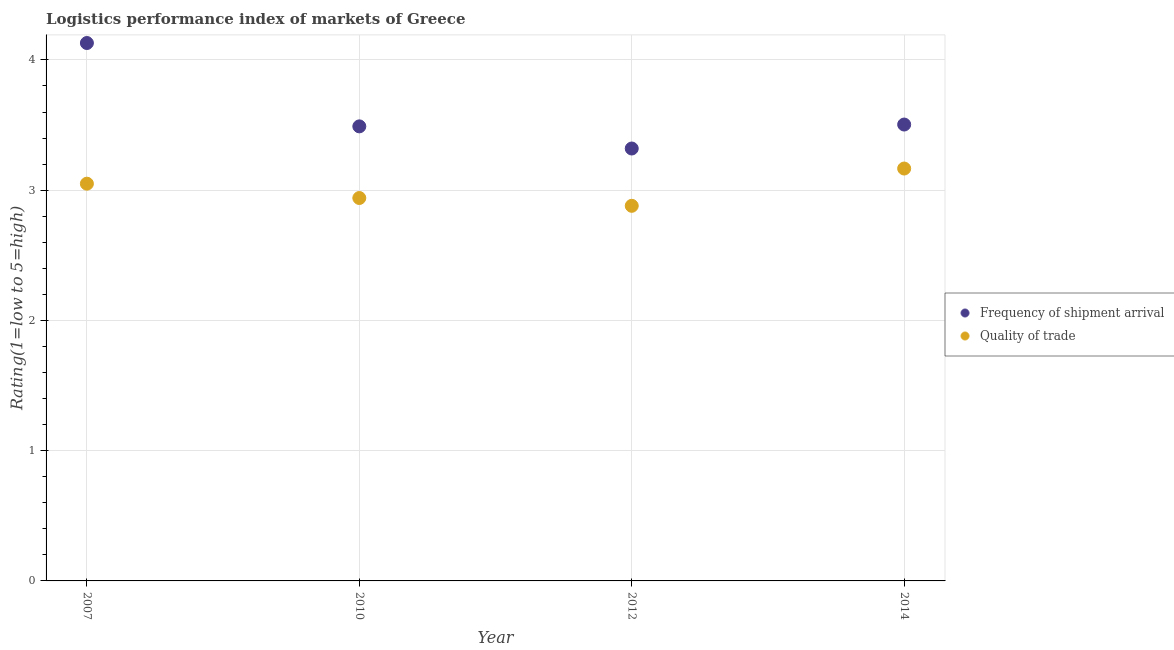Is the number of dotlines equal to the number of legend labels?
Your answer should be compact. Yes. What is the lpi quality of trade in 2007?
Provide a succinct answer. 3.05. Across all years, what is the maximum lpi quality of trade?
Ensure brevity in your answer.  3.17. Across all years, what is the minimum lpi of frequency of shipment arrival?
Provide a short and direct response. 3.32. In which year was the lpi of frequency of shipment arrival maximum?
Provide a short and direct response. 2007. In which year was the lpi quality of trade minimum?
Your response must be concise. 2012. What is the total lpi quality of trade in the graph?
Provide a short and direct response. 12.04. What is the difference between the lpi of frequency of shipment arrival in 2010 and that in 2012?
Ensure brevity in your answer.  0.17. What is the difference between the lpi quality of trade in 2010 and the lpi of frequency of shipment arrival in 2014?
Your response must be concise. -0.56. What is the average lpi of frequency of shipment arrival per year?
Offer a very short reply. 3.61. In the year 2014, what is the difference between the lpi quality of trade and lpi of frequency of shipment arrival?
Offer a terse response. -0.34. What is the ratio of the lpi quality of trade in 2007 to that in 2012?
Provide a short and direct response. 1.06. Is the difference between the lpi quality of trade in 2012 and 2014 greater than the difference between the lpi of frequency of shipment arrival in 2012 and 2014?
Give a very brief answer. No. What is the difference between the highest and the second highest lpi of frequency of shipment arrival?
Provide a succinct answer. 0.63. What is the difference between the highest and the lowest lpi quality of trade?
Provide a short and direct response. 0.29. Does the lpi of frequency of shipment arrival monotonically increase over the years?
Make the answer very short. No. Is the lpi of frequency of shipment arrival strictly greater than the lpi quality of trade over the years?
Offer a very short reply. Yes. How many dotlines are there?
Give a very brief answer. 2. How many years are there in the graph?
Keep it short and to the point. 4. What is the difference between two consecutive major ticks on the Y-axis?
Give a very brief answer. 1. Are the values on the major ticks of Y-axis written in scientific E-notation?
Your answer should be very brief. No. Does the graph contain grids?
Keep it short and to the point. Yes. How many legend labels are there?
Provide a succinct answer. 2. How are the legend labels stacked?
Offer a terse response. Vertical. What is the title of the graph?
Give a very brief answer. Logistics performance index of markets of Greece. What is the label or title of the Y-axis?
Provide a succinct answer. Rating(1=low to 5=high). What is the Rating(1=low to 5=high) in Frequency of shipment arrival in 2007?
Your answer should be very brief. 4.13. What is the Rating(1=low to 5=high) in Quality of trade in 2007?
Your answer should be very brief. 3.05. What is the Rating(1=low to 5=high) in Frequency of shipment arrival in 2010?
Ensure brevity in your answer.  3.49. What is the Rating(1=low to 5=high) of Quality of trade in 2010?
Provide a succinct answer. 2.94. What is the Rating(1=low to 5=high) in Frequency of shipment arrival in 2012?
Your answer should be compact. 3.32. What is the Rating(1=low to 5=high) of Quality of trade in 2012?
Provide a short and direct response. 2.88. What is the Rating(1=low to 5=high) in Frequency of shipment arrival in 2014?
Provide a short and direct response. 3.5. What is the Rating(1=low to 5=high) of Quality of trade in 2014?
Your answer should be very brief. 3.17. Across all years, what is the maximum Rating(1=low to 5=high) of Frequency of shipment arrival?
Offer a very short reply. 4.13. Across all years, what is the maximum Rating(1=low to 5=high) of Quality of trade?
Provide a short and direct response. 3.17. Across all years, what is the minimum Rating(1=low to 5=high) of Frequency of shipment arrival?
Provide a succinct answer. 3.32. Across all years, what is the minimum Rating(1=low to 5=high) of Quality of trade?
Give a very brief answer. 2.88. What is the total Rating(1=low to 5=high) of Frequency of shipment arrival in the graph?
Ensure brevity in your answer.  14.44. What is the total Rating(1=low to 5=high) in Quality of trade in the graph?
Offer a terse response. 12.04. What is the difference between the Rating(1=low to 5=high) in Frequency of shipment arrival in 2007 and that in 2010?
Your answer should be very brief. 0.64. What is the difference between the Rating(1=low to 5=high) of Quality of trade in 2007 and that in 2010?
Provide a succinct answer. 0.11. What is the difference between the Rating(1=low to 5=high) of Frequency of shipment arrival in 2007 and that in 2012?
Offer a terse response. 0.81. What is the difference between the Rating(1=low to 5=high) of Quality of trade in 2007 and that in 2012?
Your answer should be compact. 0.17. What is the difference between the Rating(1=low to 5=high) in Frequency of shipment arrival in 2007 and that in 2014?
Provide a short and direct response. 0.63. What is the difference between the Rating(1=low to 5=high) in Quality of trade in 2007 and that in 2014?
Keep it short and to the point. -0.12. What is the difference between the Rating(1=low to 5=high) of Frequency of shipment arrival in 2010 and that in 2012?
Your answer should be very brief. 0.17. What is the difference between the Rating(1=low to 5=high) of Frequency of shipment arrival in 2010 and that in 2014?
Provide a short and direct response. -0.01. What is the difference between the Rating(1=low to 5=high) in Quality of trade in 2010 and that in 2014?
Ensure brevity in your answer.  -0.23. What is the difference between the Rating(1=low to 5=high) in Frequency of shipment arrival in 2012 and that in 2014?
Make the answer very short. -0.18. What is the difference between the Rating(1=low to 5=high) in Quality of trade in 2012 and that in 2014?
Provide a succinct answer. -0.29. What is the difference between the Rating(1=low to 5=high) in Frequency of shipment arrival in 2007 and the Rating(1=low to 5=high) in Quality of trade in 2010?
Give a very brief answer. 1.19. What is the difference between the Rating(1=low to 5=high) in Frequency of shipment arrival in 2007 and the Rating(1=low to 5=high) in Quality of trade in 2014?
Offer a very short reply. 0.96. What is the difference between the Rating(1=low to 5=high) of Frequency of shipment arrival in 2010 and the Rating(1=low to 5=high) of Quality of trade in 2012?
Offer a very short reply. 0.61. What is the difference between the Rating(1=low to 5=high) of Frequency of shipment arrival in 2010 and the Rating(1=low to 5=high) of Quality of trade in 2014?
Offer a very short reply. 0.32. What is the difference between the Rating(1=low to 5=high) in Frequency of shipment arrival in 2012 and the Rating(1=low to 5=high) in Quality of trade in 2014?
Provide a succinct answer. 0.15. What is the average Rating(1=low to 5=high) in Frequency of shipment arrival per year?
Make the answer very short. 3.61. What is the average Rating(1=low to 5=high) of Quality of trade per year?
Make the answer very short. 3.01. In the year 2010, what is the difference between the Rating(1=low to 5=high) in Frequency of shipment arrival and Rating(1=low to 5=high) in Quality of trade?
Make the answer very short. 0.55. In the year 2012, what is the difference between the Rating(1=low to 5=high) of Frequency of shipment arrival and Rating(1=low to 5=high) of Quality of trade?
Your answer should be compact. 0.44. In the year 2014, what is the difference between the Rating(1=low to 5=high) of Frequency of shipment arrival and Rating(1=low to 5=high) of Quality of trade?
Your response must be concise. 0.34. What is the ratio of the Rating(1=low to 5=high) in Frequency of shipment arrival in 2007 to that in 2010?
Offer a terse response. 1.18. What is the ratio of the Rating(1=low to 5=high) of Quality of trade in 2007 to that in 2010?
Provide a succinct answer. 1.04. What is the ratio of the Rating(1=low to 5=high) of Frequency of shipment arrival in 2007 to that in 2012?
Keep it short and to the point. 1.24. What is the ratio of the Rating(1=low to 5=high) in Quality of trade in 2007 to that in 2012?
Your answer should be very brief. 1.06. What is the ratio of the Rating(1=low to 5=high) in Frequency of shipment arrival in 2007 to that in 2014?
Your answer should be very brief. 1.18. What is the ratio of the Rating(1=low to 5=high) of Quality of trade in 2007 to that in 2014?
Your answer should be compact. 0.96. What is the ratio of the Rating(1=low to 5=high) of Frequency of shipment arrival in 2010 to that in 2012?
Offer a very short reply. 1.05. What is the ratio of the Rating(1=low to 5=high) of Quality of trade in 2010 to that in 2012?
Your response must be concise. 1.02. What is the ratio of the Rating(1=low to 5=high) in Frequency of shipment arrival in 2010 to that in 2014?
Give a very brief answer. 1. What is the ratio of the Rating(1=low to 5=high) in Quality of trade in 2010 to that in 2014?
Offer a terse response. 0.93. What is the ratio of the Rating(1=low to 5=high) in Frequency of shipment arrival in 2012 to that in 2014?
Your answer should be compact. 0.95. What is the ratio of the Rating(1=low to 5=high) of Quality of trade in 2012 to that in 2014?
Provide a short and direct response. 0.91. What is the difference between the highest and the second highest Rating(1=low to 5=high) of Frequency of shipment arrival?
Your answer should be very brief. 0.63. What is the difference between the highest and the second highest Rating(1=low to 5=high) in Quality of trade?
Your response must be concise. 0.12. What is the difference between the highest and the lowest Rating(1=low to 5=high) in Frequency of shipment arrival?
Make the answer very short. 0.81. What is the difference between the highest and the lowest Rating(1=low to 5=high) of Quality of trade?
Provide a short and direct response. 0.29. 